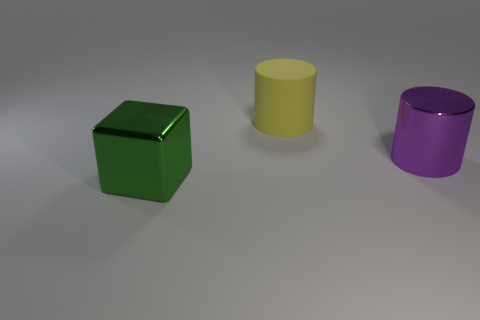Subtract all yellow cylinders. Subtract all purple spheres. How many cylinders are left? 1 Add 1 large objects. How many objects exist? 4 Subtract all cubes. How many objects are left? 2 Add 1 tiny green shiny balls. How many tiny green shiny balls exist? 1 Subtract 0 gray balls. How many objects are left? 3 Subtract all matte objects. Subtract all big matte things. How many objects are left? 1 Add 3 green shiny things. How many green shiny things are left? 4 